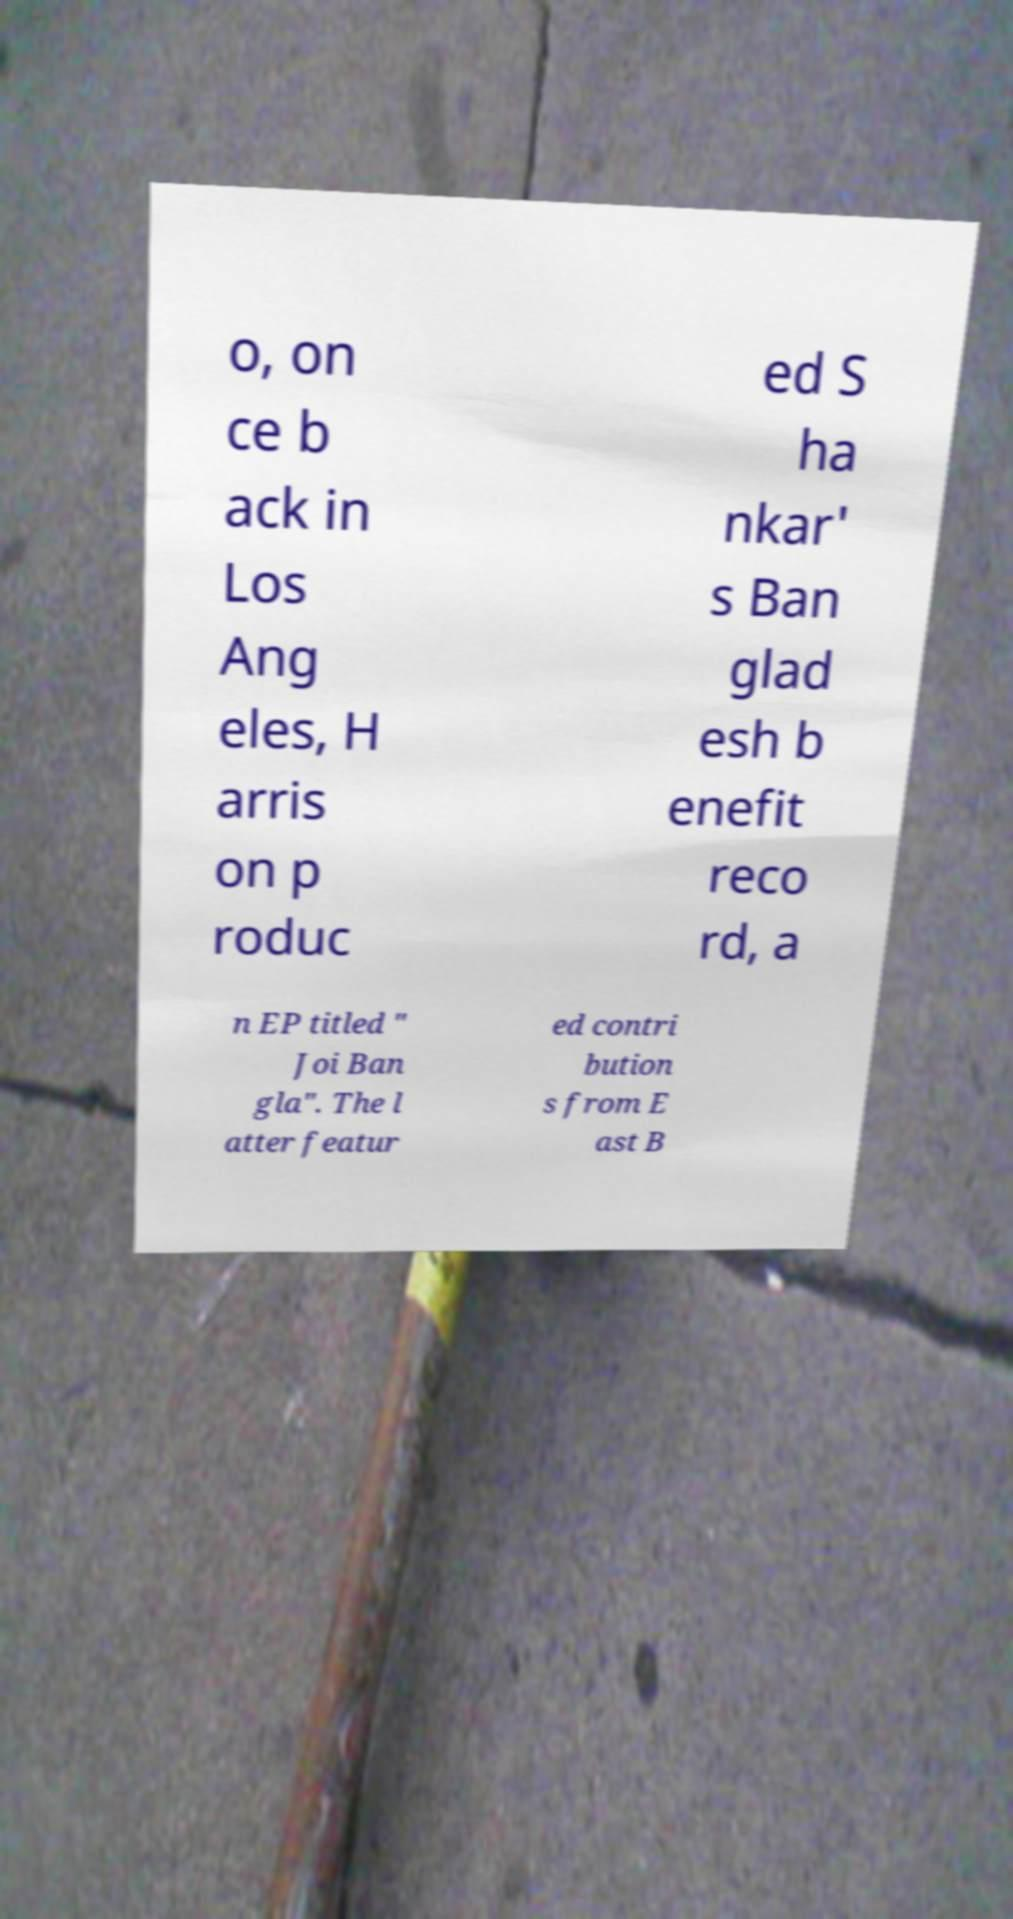Can you accurately transcribe the text from the provided image for me? o, on ce b ack in Los Ang eles, H arris on p roduc ed S ha nkar' s Ban glad esh b enefit reco rd, a n EP titled " Joi Ban gla". The l atter featur ed contri bution s from E ast B 